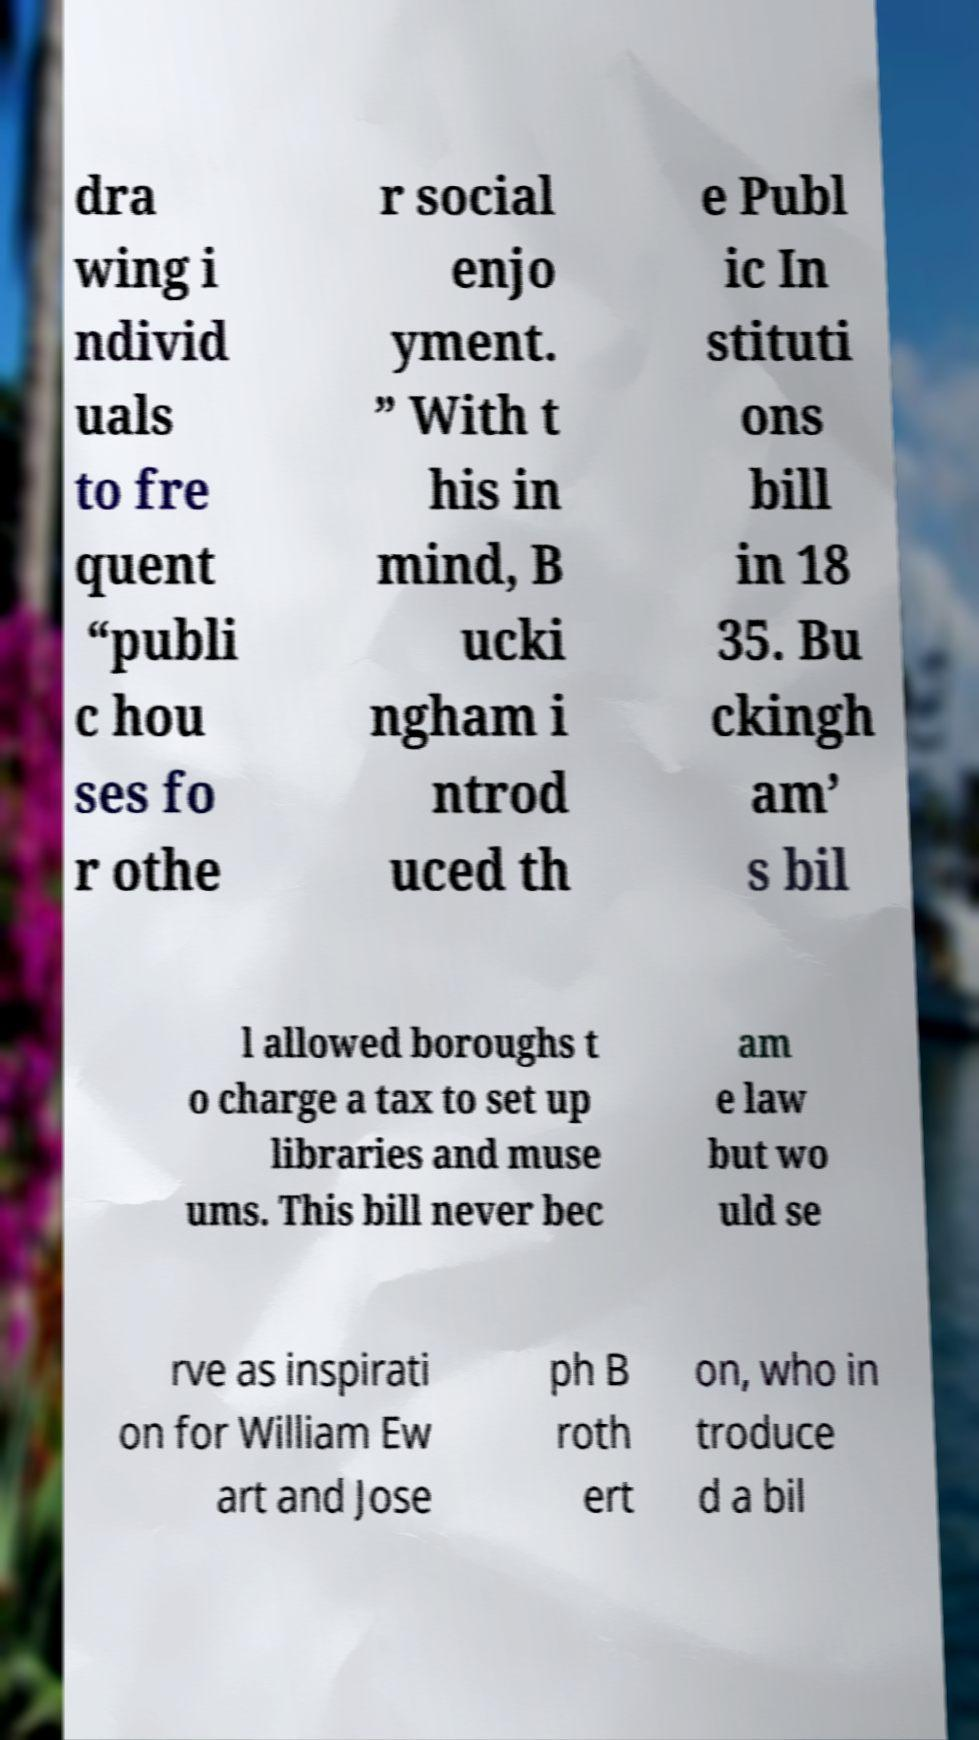Please read and relay the text visible in this image. What does it say? dra wing i ndivid uals to fre quent “publi c hou ses fo r othe r social enjo yment. ” With t his in mind, B ucki ngham i ntrod uced th e Publ ic In stituti ons bill in 18 35. Bu ckingh am’ s bil l allowed boroughs t o charge a tax to set up libraries and muse ums. This bill never bec am e law but wo uld se rve as inspirati on for William Ew art and Jose ph B roth ert on, who in troduce d a bil 